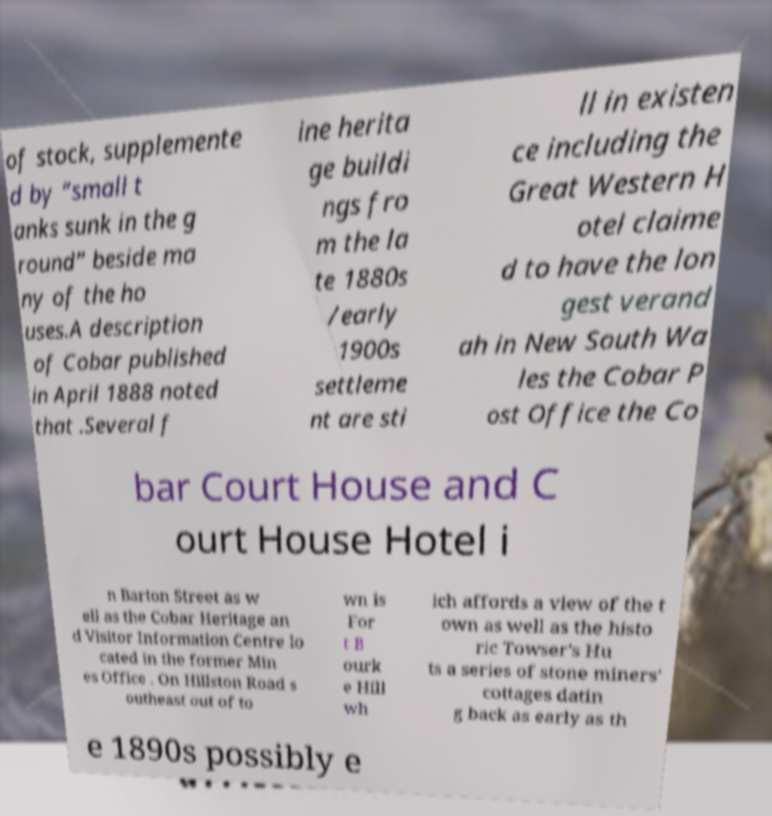Can you accurately transcribe the text from the provided image for me? of stock, supplemente d by “small t anks sunk in the g round” beside ma ny of the ho uses.A description of Cobar published in April 1888 noted that .Several f ine herita ge buildi ngs fro m the la te 1880s /early 1900s settleme nt are sti ll in existen ce including the Great Western H otel claime d to have the lon gest verand ah in New South Wa les the Cobar P ost Office the Co bar Court House and C ourt House Hotel i n Barton Street as w ell as the Cobar Heritage an d Visitor Information Centre lo cated in the former Min es Office . On Hillston Road s outheast out of to wn is For t B ourk e Hill wh ich affords a view of the t own as well as the histo ric Towser's Hu ts a series of stone miners' cottages datin g back as early as th e 1890s possibly e 